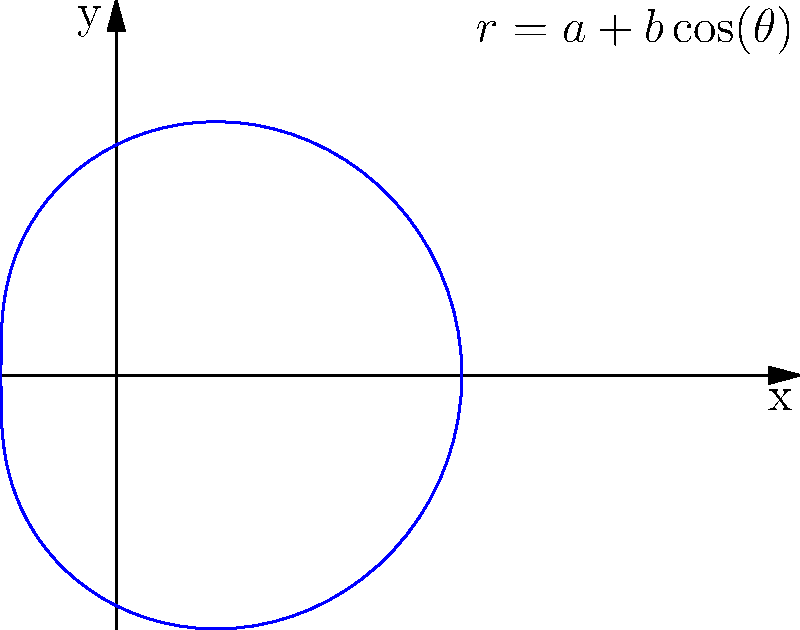Your daughter is studying marine biology and has asked for your help in understanding the mathematical model of a seashell. The shape of the seashell can be approximated by a limacon curve with the polar equation $r = a + b\cos(\theta)$, where $a$ and $b$ are positive constants. If $a = 2$ and $b = 1$, what type of limacon curve does this represent? Let's approach this step-by-step:

1) The general equation for a limacon curve is $r = a + b\cos(\theta)$, where $a$ and $b$ are constants.

2) The type of limacon depends on the relationship between $a$ and $b$:
   - If $a > b$, it's a dimpled limacon
   - If $a = b$, it's a cardioid
   - If $a < b$, it's a looped limacon

3) In this case, we're given that $a = 2$ and $b = 1$.

4) Comparing these values:
   $a = 2$ and $b = 1$
   $2 > 1$
   Therefore, $a > b$

5) Since $a > b$, this represents a dimpled limacon.

6) You can see from the graph that the curve forms a dimpled shape, without any loops or cusps.
Answer: Dimpled limacon 